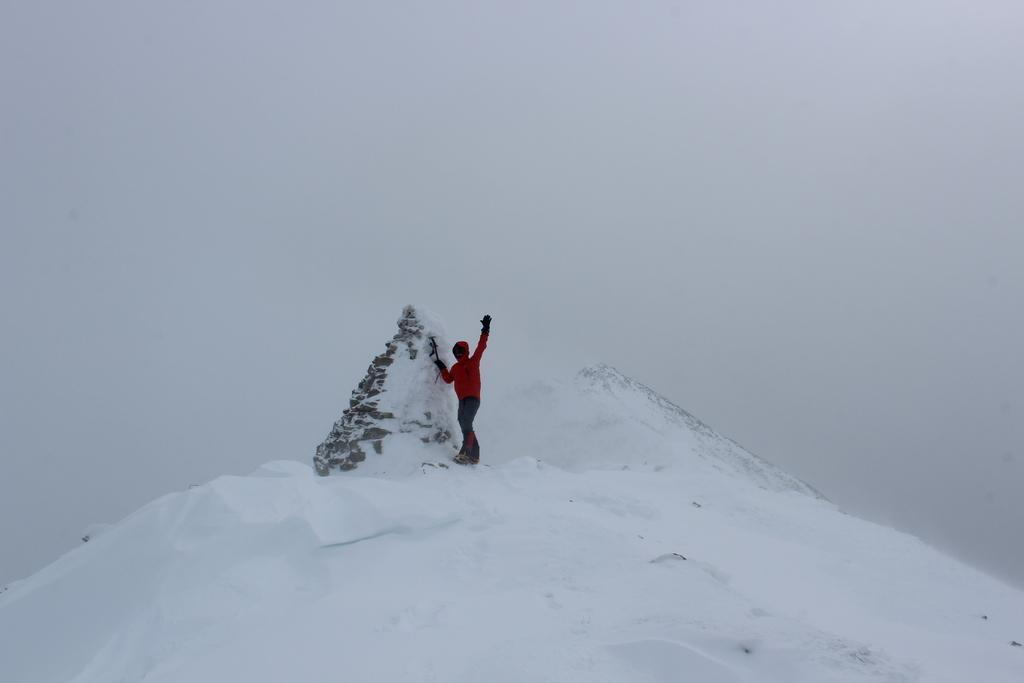What is covering the ground in the image? There is snow on the ground in the image. Can you describe the person in the image? There is a person standing in the image. What is the condition of the sky in the image? The sky is cloudy in the image. Where is the kitty playing in the shade in the image? There is no kitty or shade present in the image; it features snow on the ground and a person standing. What type of train can be seen passing by in the image? There is no train present in the image. 